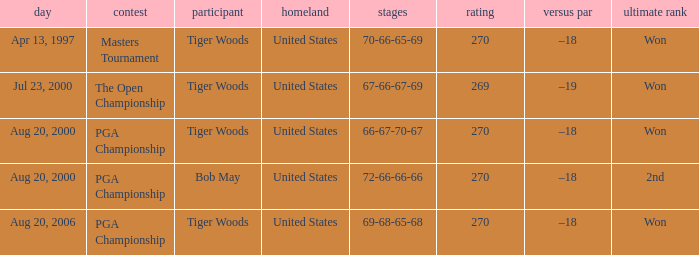What is the most terrible (highest) score? 270.0. 